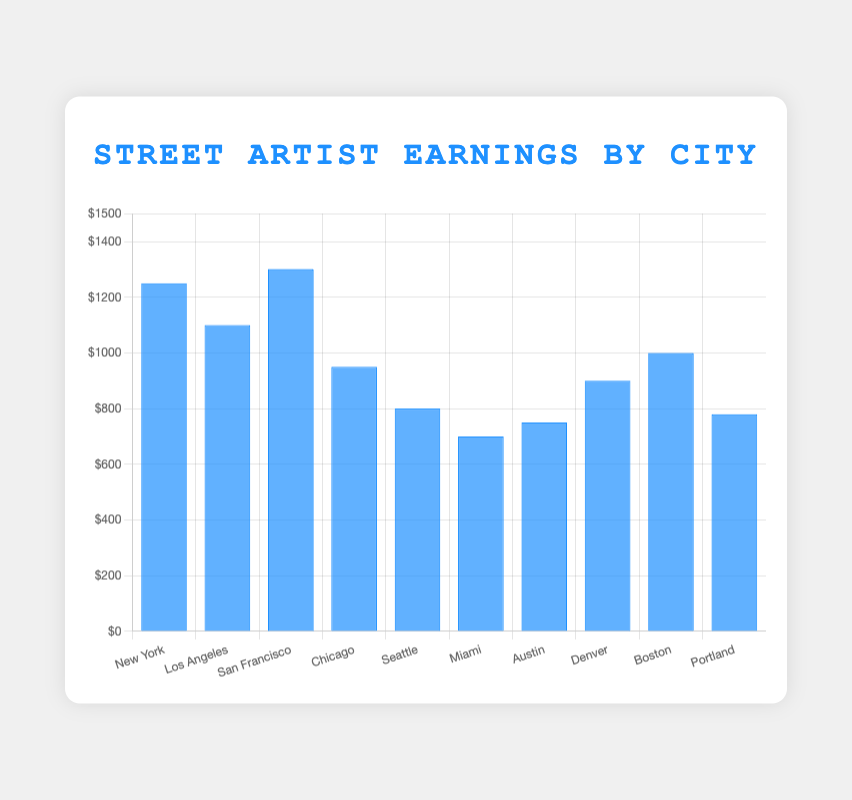Which city has the highest average earning for street artists? The bar representing San Francisco is the tallest, with an average earning of $1300.
Answer: San Francisco Which city has the lowest average earning for street artists? The bar representing Miami is the shortest, with an average earning of $700.
Answer: Miami What's the difference in average earning between the street artists in New York and Chicago? The average earning in New York is $1250 and in Chicago is $950. The difference is $1250 - $950 = $300.
Answer: $300 Which cities have an average earning greater than $1000? The cities with bars taller than the $1000 mark are New York, Los Angeles, and San Francisco.
Answer: New York, Los Angeles, San Francisco What's the total average earning for street artists in Los Angeles, San Francisco, and Seattle combined? Summing the average earnings of Los Angeles ($1100), San Francisco ($1300), and Seattle ($800) gives $1100 + $1300 + $800 = $3200.
Answer: $3200 How does the average earning in Boston compare to that in Portland? The bar for Boston ($1000) is taller than the bar for Portland ($780).
Answer: Boston has higher earnings Which cities have an average earning between $750 and $1000? The cities with bars within this range are Chicago ($950), Denver ($900), Boston ($1000), Austin ($750), and Portland ($780).
Answer: Chicago, Denver, Boston, Austin, Portland What is the average earning difference between the highest and lowest earning cities? The highest earning city is San Francisco ($1300) and the lowest is Miami ($700). The difference is $1300 - $700 = $600.
Answer: $600 What is the combined average earning for the cities with the three lowest earnings? Miami ($700), Austin ($750), and Portland ($780) have the lowest earnings. Their combined total is $700 + $750 + $780 = $2230.
Answer: $2230 If you line up the cities from highest to lowest earnings, which city is in the middle? Arranging earnings: San Francisco ($1300), New York ($1250), Los Angeles ($1100), Boston ($1000), Chicago ($950), Denver ($900), Austin ($750), Portland ($780), Seattle ($800), Miami ($700). Middle city is Austin.
Answer: Austin 